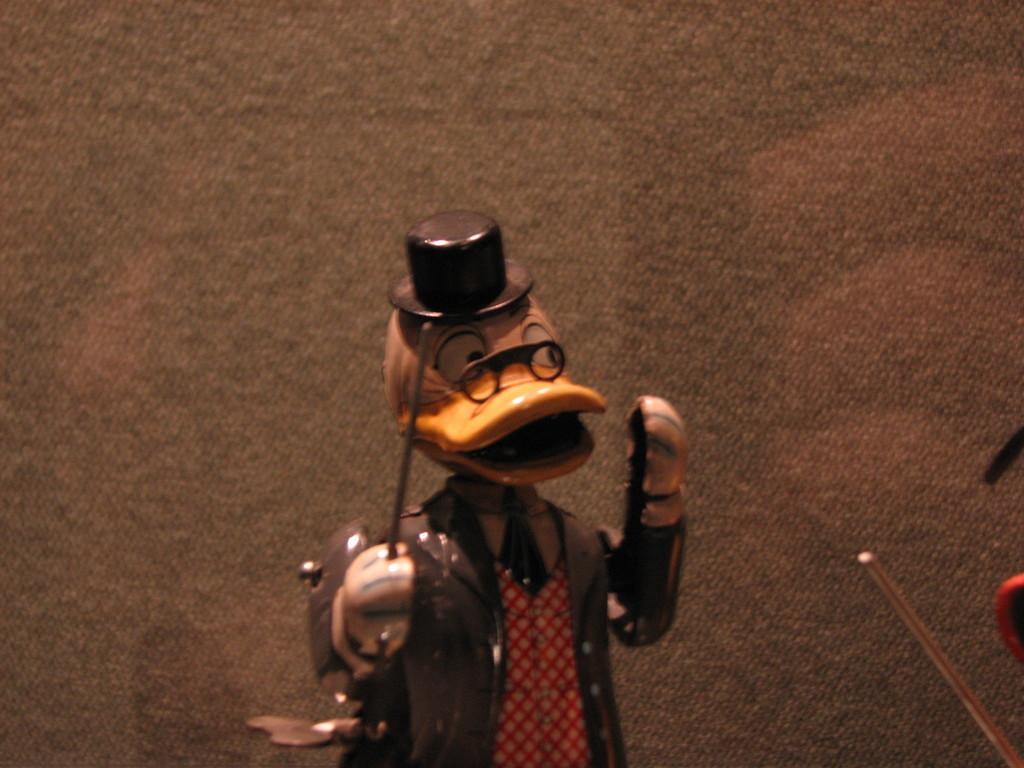In one or two sentences, can you explain what this image depicts? In the picture I can see sculpture of a cartoon character who is wearing a hat and holding a stick. I can also see some other objects. 